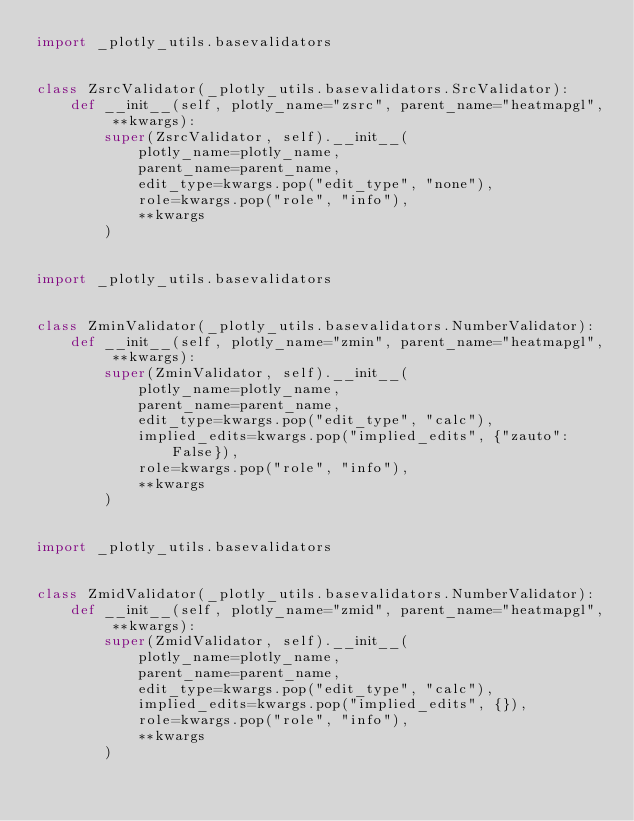<code> <loc_0><loc_0><loc_500><loc_500><_Python_>import _plotly_utils.basevalidators


class ZsrcValidator(_plotly_utils.basevalidators.SrcValidator):
    def __init__(self, plotly_name="zsrc", parent_name="heatmapgl", **kwargs):
        super(ZsrcValidator, self).__init__(
            plotly_name=plotly_name,
            parent_name=parent_name,
            edit_type=kwargs.pop("edit_type", "none"),
            role=kwargs.pop("role", "info"),
            **kwargs
        )


import _plotly_utils.basevalidators


class ZminValidator(_plotly_utils.basevalidators.NumberValidator):
    def __init__(self, plotly_name="zmin", parent_name="heatmapgl", **kwargs):
        super(ZminValidator, self).__init__(
            plotly_name=plotly_name,
            parent_name=parent_name,
            edit_type=kwargs.pop("edit_type", "calc"),
            implied_edits=kwargs.pop("implied_edits", {"zauto": False}),
            role=kwargs.pop("role", "info"),
            **kwargs
        )


import _plotly_utils.basevalidators


class ZmidValidator(_plotly_utils.basevalidators.NumberValidator):
    def __init__(self, plotly_name="zmid", parent_name="heatmapgl", **kwargs):
        super(ZmidValidator, self).__init__(
            plotly_name=plotly_name,
            parent_name=parent_name,
            edit_type=kwargs.pop("edit_type", "calc"),
            implied_edits=kwargs.pop("implied_edits", {}),
            role=kwargs.pop("role", "info"),
            **kwargs
        )

</code> 